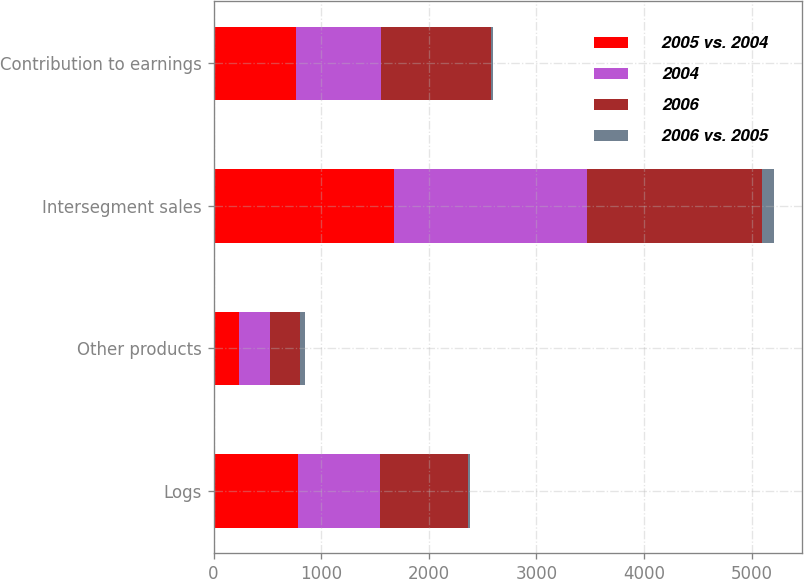Convert chart. <chart><loc_0><loc_0><loc_500><loc_500><stacked_bar_chart><ecel><fcel>Logs<fcel>Other products<fcel>Intersegment sales<fcel>Contribution to earnings<nl><fcel>2005 vs. 2004<fcel>781<fcel>235<fcel>1675<fcel>767<nl><fcel>2004<fcel>761<fcel>286<fcel>1794<fcel>784<nl><fcel>2006<fcel>822<fcel>280<fcel>1622<fcel>1027<nl><fcel>2006 vs. 2005<fcel>20<fcel>51<fcel>119<fcel>17<nl></chart> 